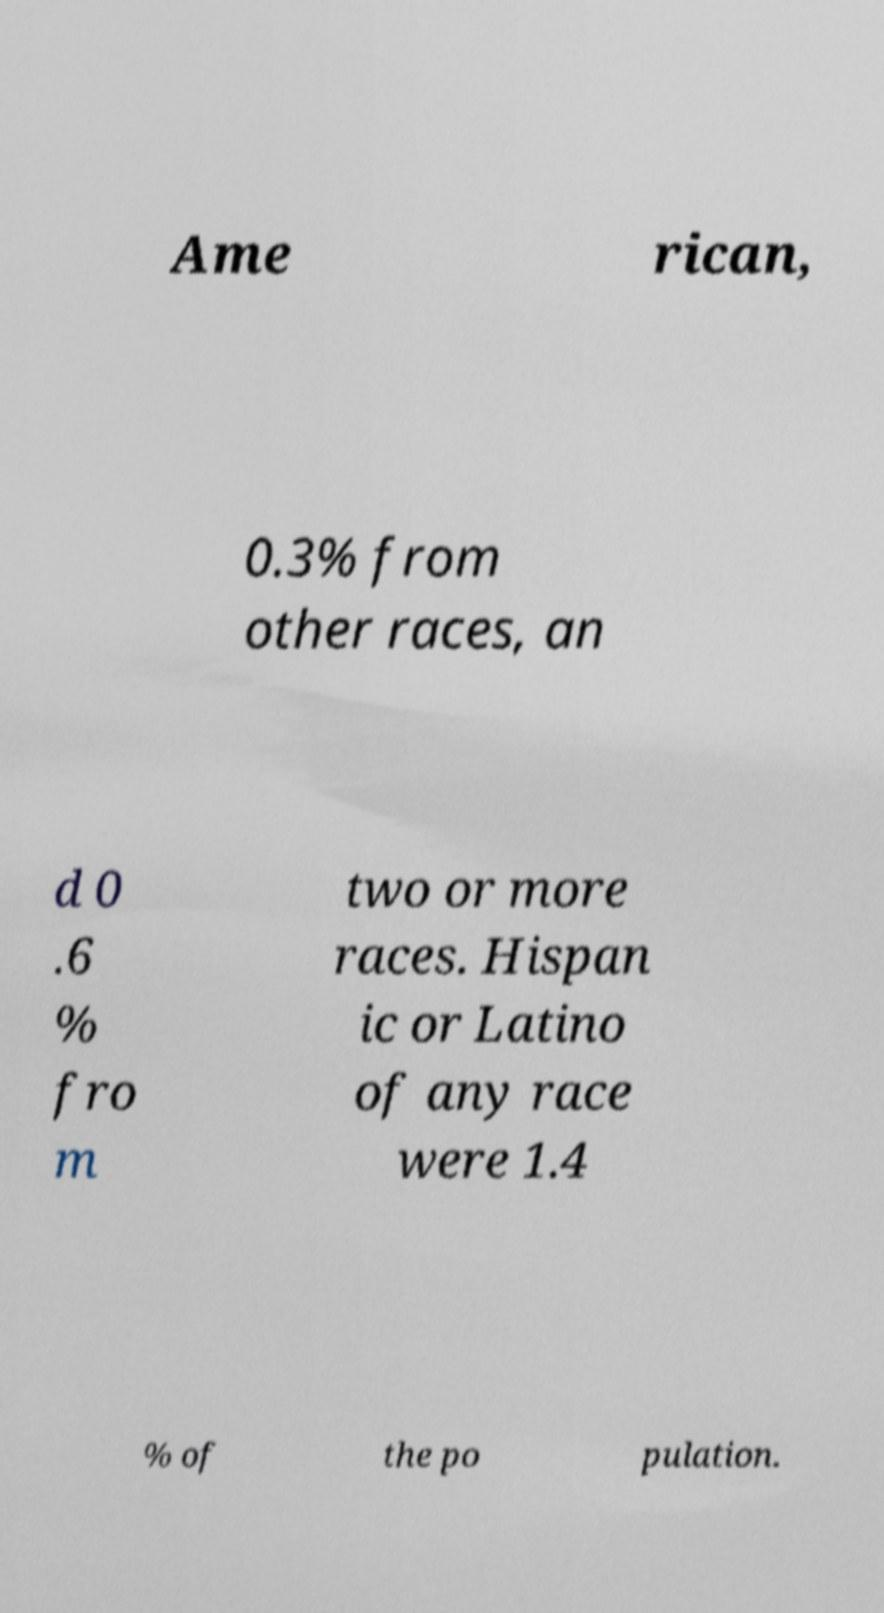I need the written content from this picture converted into text. Can you do that? Ame rican, 0.3% from other races, an d 0 .6 % fro m two or more races. Hispan ic or Latino of any race were 1.4 % of the po pulation. 